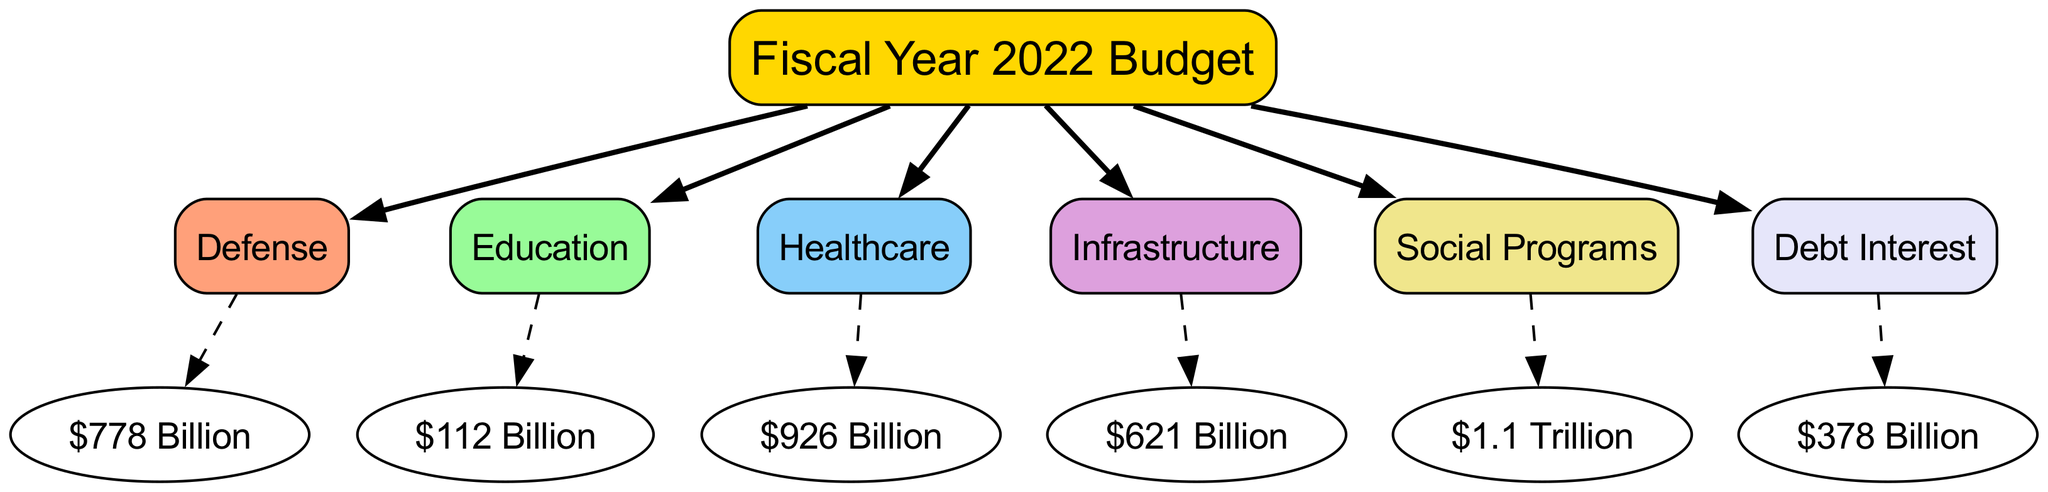What is the total budget for Defense in the fiscal year 2022? The diagram indicates that the allocated budget for Defense is specifically stated as $778 Billion, which is directly connected to the Defense node under the main Fiscal Year 2022 Budget node.
Answer: $778 Billion How much is allocated for Healthcare compared to Education? The Healthcare budget is $926 Billion, while Education has a budget of $112 Billion. When comparing these, Healthcare has significantly more than Education, with the difference being $814 Billion.
Answer: $814 Billion Which sector receives the highest allocation of funds? By reviewing the amounts next to each sector, it is clear that Healthcare has the highest allocation at $926 Billion, surpassing all other sectors in the diagram.
Answer: Healthcare How many sectors are represented in the diagram? The diagram features a total of 7 sectors connected to the main Fiscal Year 2022 Budget node, each representing a different allocation of funds.
Answer: 7 What percentage of the total budget is allocated to Social Programs? To determine this, first sum all the allocations: Defense ($778B) + Education ($112B) + Healthcare ($926B) + Infrastructure ($621B) + Social Programs ($1.1T, which is $1,100B) + Debt Interest ($378B) = $3,915 Billion. Social Programs' allocation of $1.1T then constitutes $1,100B ÷ $3,915B ≈ 28.1%. Thus, the approximate percentage of the total budget for Social Programs is 28.1%.
Answer: 28.1% What is the relationship between Debt Interest and the overall budget? The Debt Interest is one of the sectors within the diagram linked under the Fiscal Year 2022 Budget. It shows how funds are allocated specifically to manage interest payments on national debt, amounting to $378 Billion as reflected in the diagram. It is a financial obligation that is part of the overall budgetary expenditures.
Answer: Linked sector What is the budget for Infrastructure? The Infrastructure budget is explicitly stated in the diagram as $621 Billion, and this value is directly connected to the Infrastructure node.
Answer: $621 Billion How is the budget structured in terms of major categories? The diagram categorically divides the budget into several key sectors including Defense, Education, Healthcare, Infrastructure, Social Programs, and Debt Interest, each receiving a distinct allocation and essentially illustrating a structural overview of fiscal priority areas.
Answer: Sectorally divided What is the total budget amount depicted in the diagram? By adding the amounts specified in the sectors, we calculate the total: $778B + $112B + $926B + $621B + $1,100B + $378B = $3,915 Billion. This total represents the comprehensive allocation of government funds as expressed in the fiscal budget chart.
Answer: $3,915 Billion 